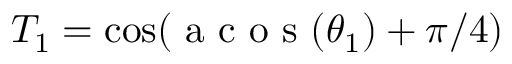<formula> <loc_0><loc_0><loc_500><loc_500>T _ { 1 } = \cos ( a c o s ( \theta _ { 1 } ) + \pi / 4 )</formula> 